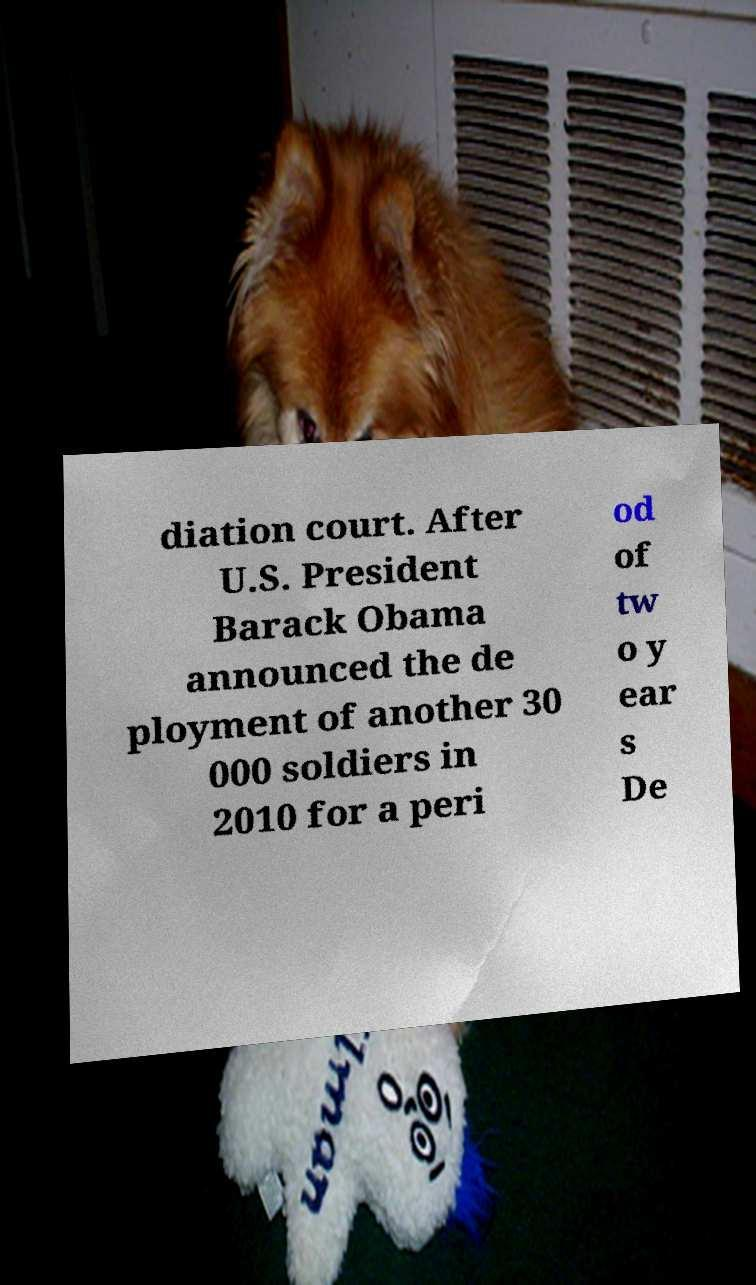What messages or text are displayed in this image? I need them in a readable, typed format. diation court. After U.S. President Barack Obama announced the de ployment of another 30 000 soldiers in 2010 for a peri od of tw o y ear s De 